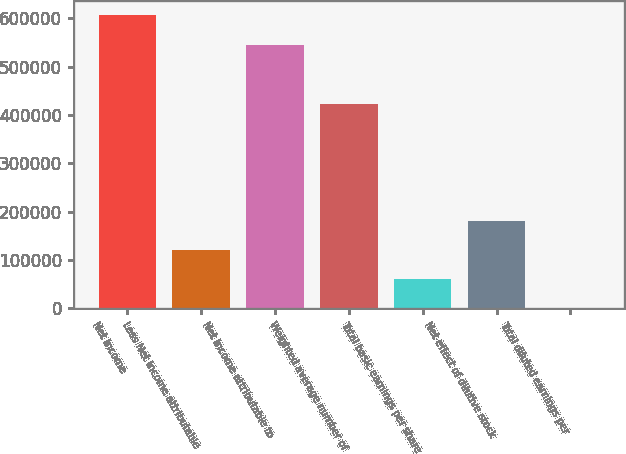Convert chart to OTSL. <chart><loc_0><loc_0><loc_500><loc_500><bar_chart><fcel>Net Income<fcel>Less Net income attributable<fcel>Net income attributable to<fcel>Weighted average number of<fcel>Total basic earnings per share<fcel>Net effect of dilutive stock<fcel>Total diluted earnings per<nl><fcel>605606<fcel>121004<fcel>545107<fcel>423499<fcel>60504.5<fcel>181503<fcel>5.42<nl></chart> 